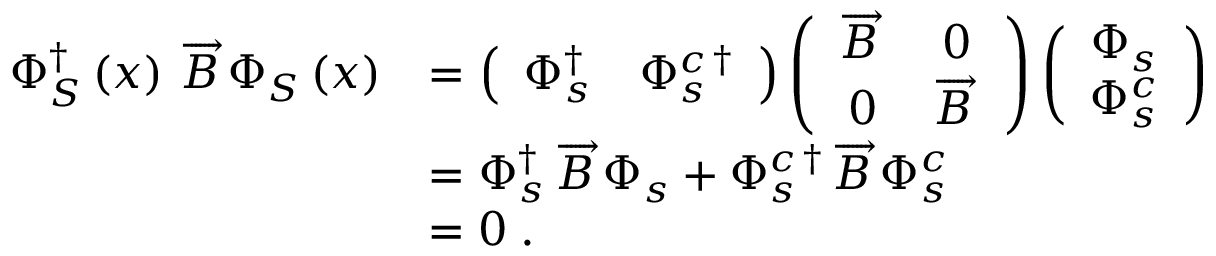Convert formula to latex. <formula><loc_0><loc_0><loc_500><loc_500>\begin{array} { r l } { \Phi _ { S } ^ { \dag } \left ( x \right ) \, \overrightarrow { B } \, \Phi _ { S } \left ( x \right ) } & { = \left ( \begin{array} { c c } { \Phi _ { s } ^ { \dag } } & { \Phi _ { s } ^ { c \, \dag } } \end{array} \right ) \left ( \begin{array} { c c } { \overrightarrow { B } \, } & { 0 } \\ { 0 } & { \overrightarrow { B } \, } \end{array} \right ) \left ( \begin{array} { c } { \Phi _ { s } } \\ { \Phi _ { s } ^ { c } } \end{array} \right ) } \\ & { = \Phi _ { s } ^ { \dag } \, \overrightarrow { B } \, \Phi _ { s } + \Phi _ { s } ^ { c \, \dag } \, \overrightarrow { B } \, \Phi _ { s } ^ { c } } \\ & { = 0 \, . } \end{array}</formula> 